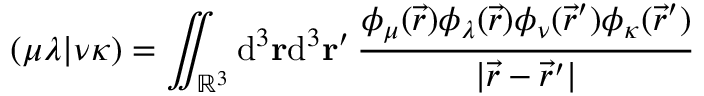Convert formula to latex. <formula><loc_0><loc_0><loc_500><loc_500>( \mu \lambda | \nu \kappa ) = \iint _ { \mathbb { R } ^ { 3 } } d ^ { 3 } r d ^ { 3 } r ^ { \prime } \, \frac { \phi _ { \mu } ( \vec { r } ) \phi _ { \lambda } ( \vec { r } ) \phi _ { \nu } ( \vec { r } ^ { \prime } ) \phi _ { \kappa } ( \vec { r } ^ { \prime } ) } { | \vec { r } - \vec { r } ^ { \prime } | }</formula> 